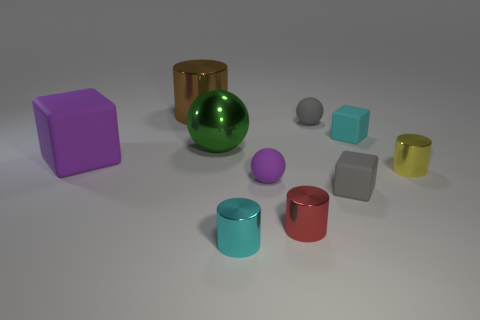Does the cyan metal cylinder have the same size as the purple thing on the left side of the large shiny ball? No, the cyan metal cylinder does not have the same size as the purple cube. While it's difficult to accurately measure without a reference scale, it appears that the cyan cylinder is slightly shorter in height but has a wider diameter than the purple object when viewing them in relation to the large shiny green ball that is centrally situated between them. 